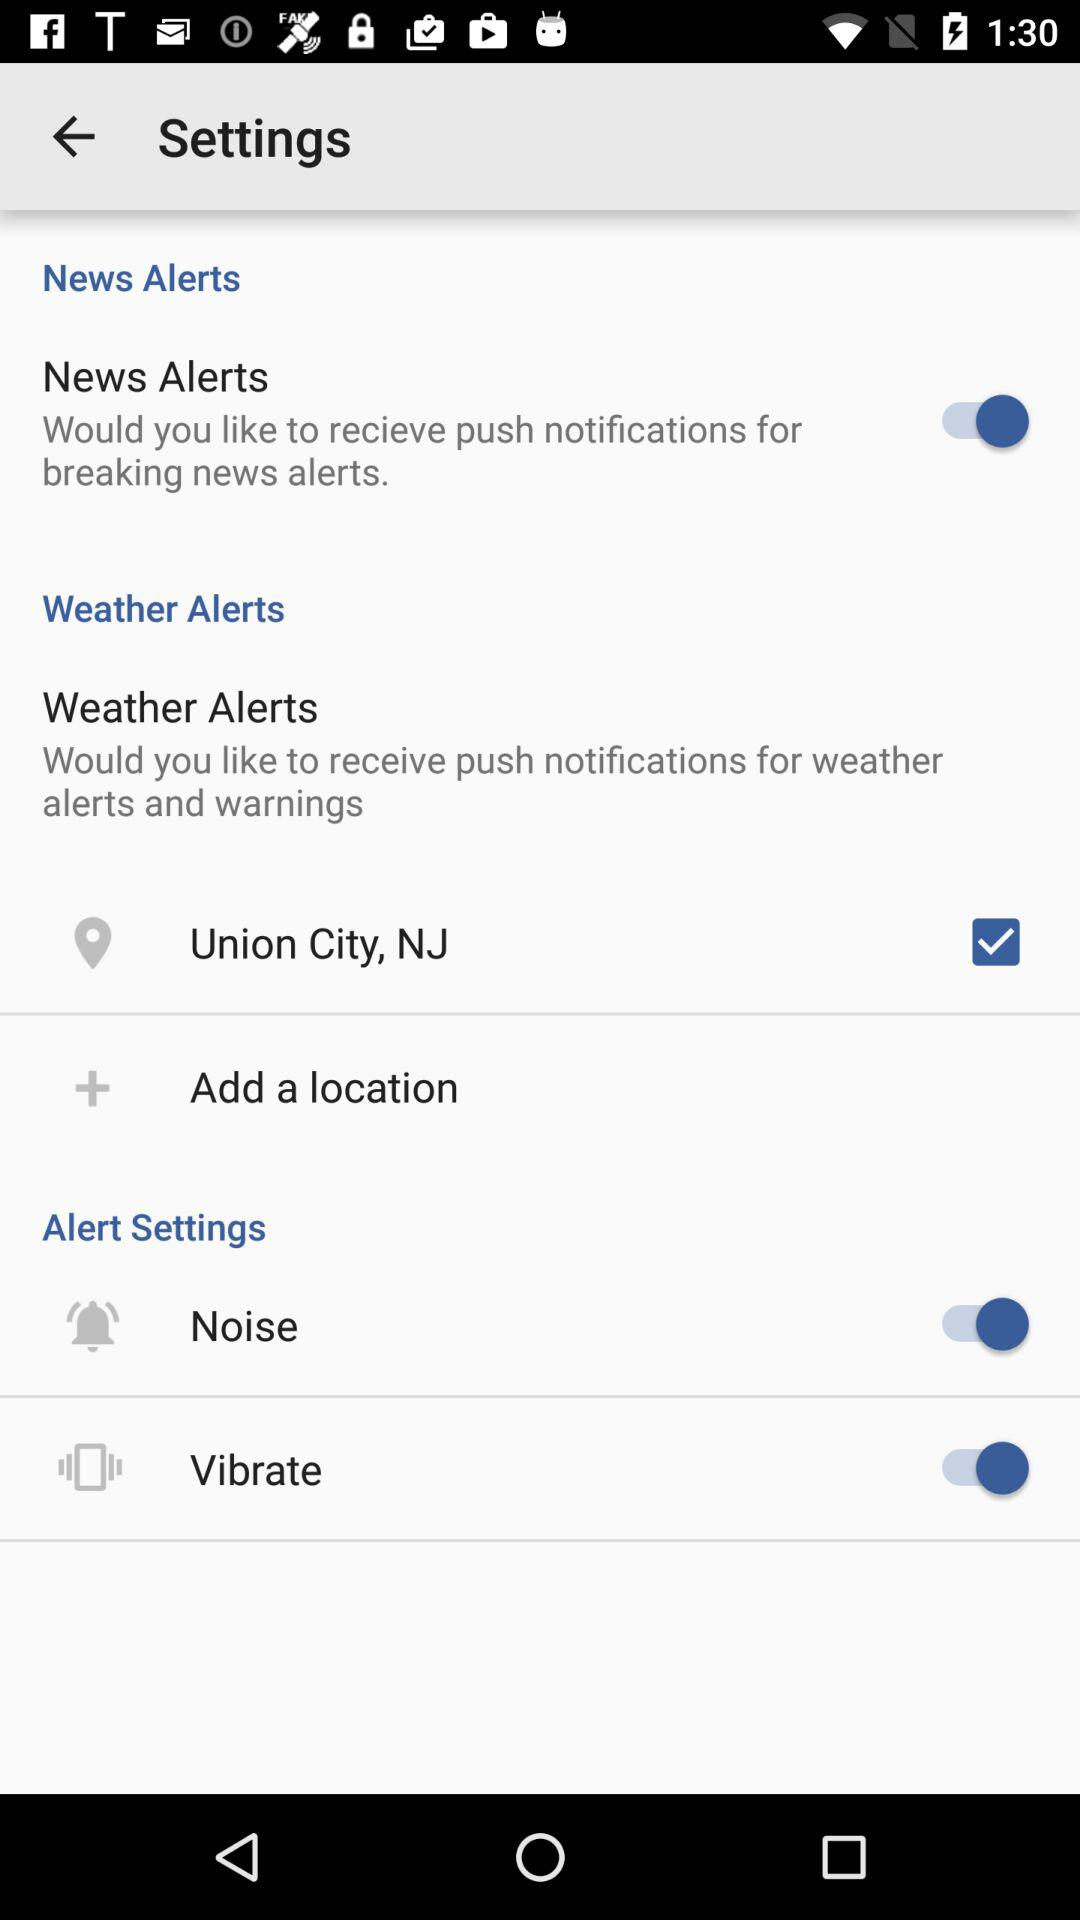What is the status of "Noise"? The status is "on". 